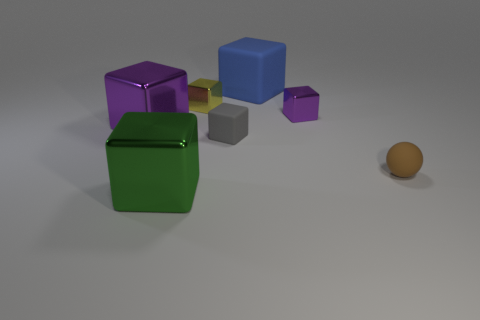What number of big things are either blue shiny spheres or gray blocks?
Offer a terse response. 0. What color is the large thing in front of the purple cube in front of the purple metal block to the right of the yellow thing?
Give a very brief answer. Green. What number of other things are the same color as the rubber sphere?
Keep it short and to the point. 0. How many matte things are either cubes or red cylinders?
Provide a succinct answer. 2. There is a tiny cube that is to the right of the blue block; is its color the same as the big metallic object on the left side of the large green shiny object?
Make the answer very short. Yes. Is there anything else that has the same material as the brown sphere?
Make the answer very short. Yes. What is the size of the gray object that is the same shape as the green object?
Make the answer very short. Small. Is the number of small shiny cubes to the left of the tiny gray thing greater than the number of large green matte cylinders?
Your answer should be very brief. Yes. Is the material of the thing that is in front of the matte sphere the same as the tiny brown object?
Offer a terse response. No. What is the size of the shiny cube that is to the right of the tiny matte thing that is behind the tiny brown matte ball in front of the gray cube?
Your response must be concise. Small. 